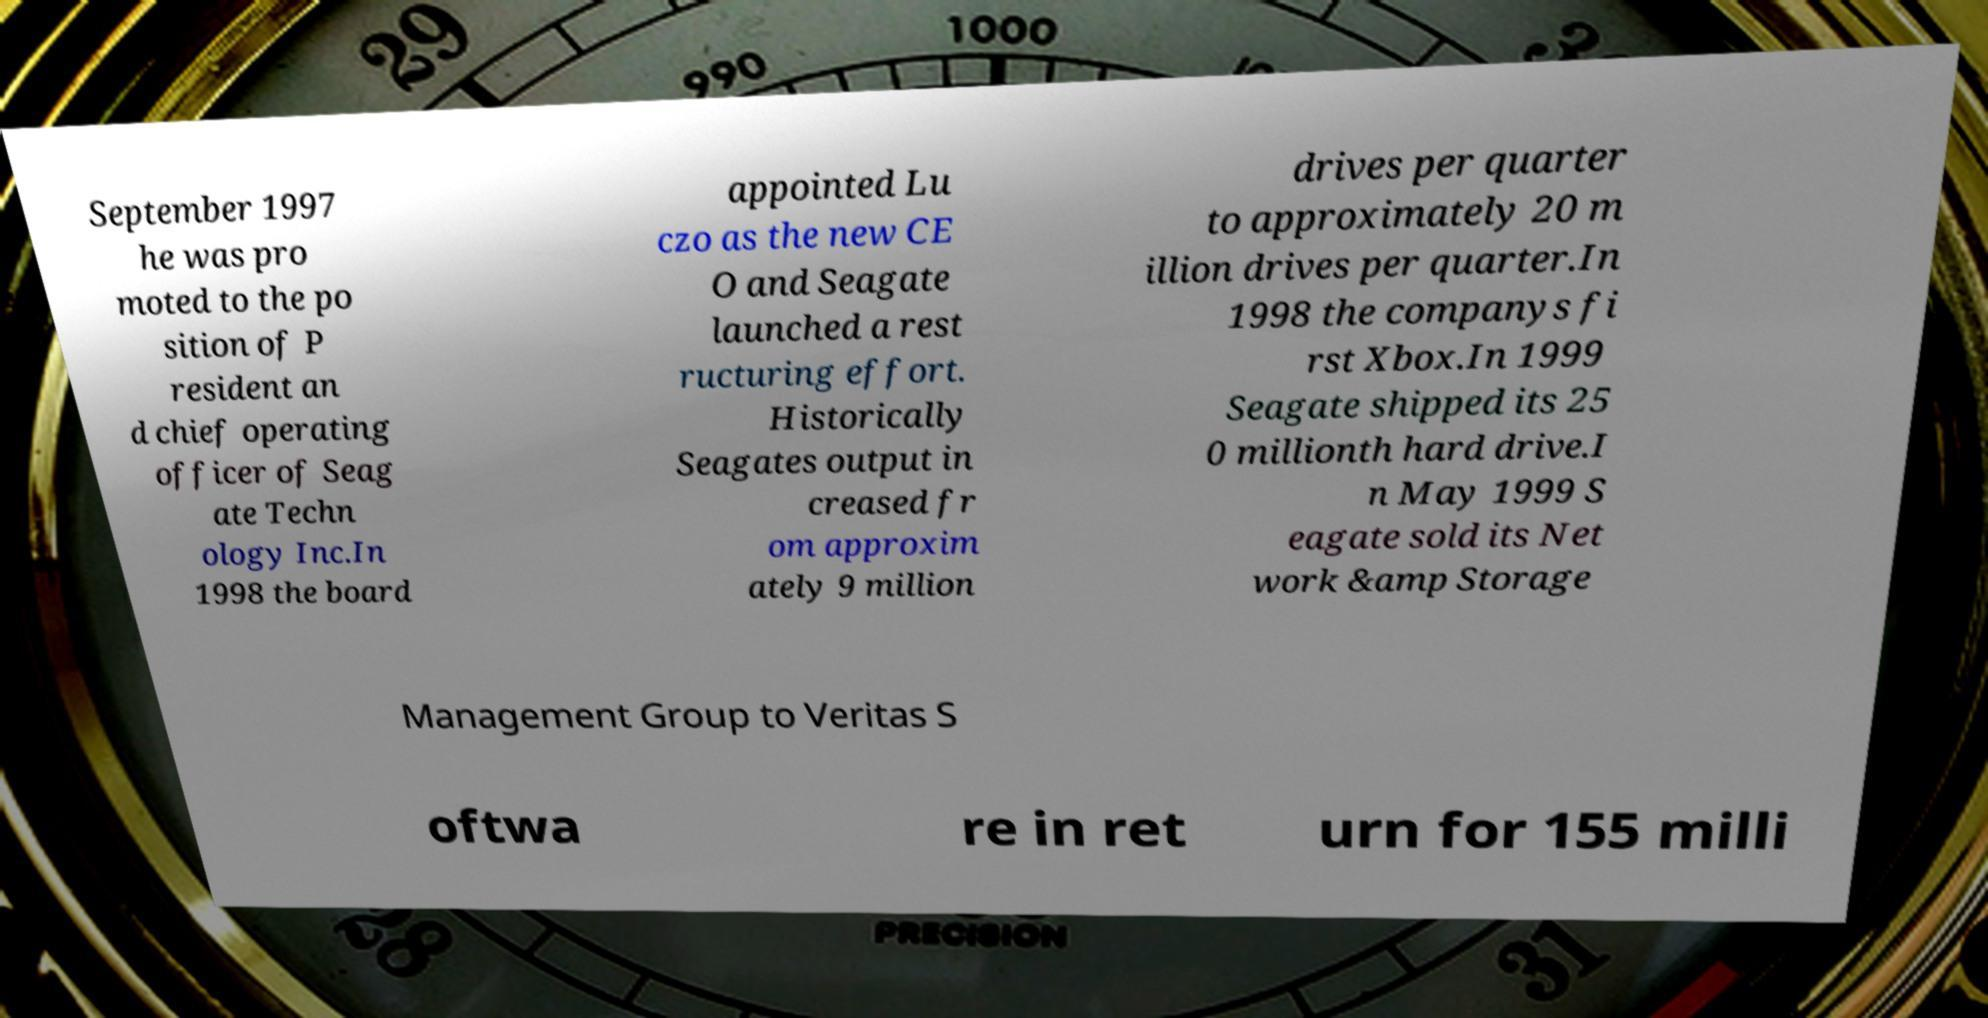I need the written content from this picture converted into text. Can you do that? September 1997 he was pro moted to the po sition of P resident an d chief operating officer of Seag ate Techn ology Inc.In 1998 the board appointed Lu czo as the new CE O and Seagate launched a rest ructuring effort. Historically Seagates output in creased fr om approxim ately 9 million drives per quarter to approximately 20 m illion drives per quarter.In 1998 the companys fi rst Xbox.In 1999 Seagate shipped its 25 0 millionth hard drive.I n May 1999 S eagate sold its Net work &amp Storage Management Group to Veritas S oftwa re in ret urn for 155 milli 